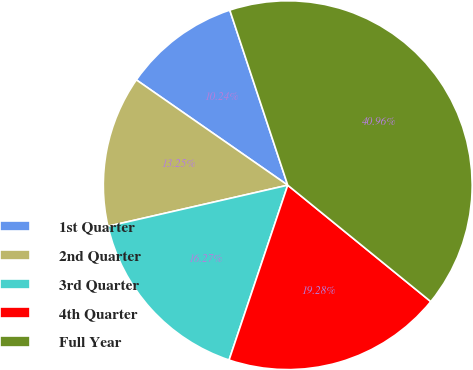Convert chart. <chart><loc_0><loc_0><loc_500><loc_500><pie_chart><fcel>1st Quarter<fcel>2nd Quarter<fcel>3rd Quarter<fcel>4th Quarter<fcel>Full Year<nl><fcel>10.24%<fcel>13.25%<fcel>16.27%<fcel>19.28%<fcel>40.96%<nl></chart> 